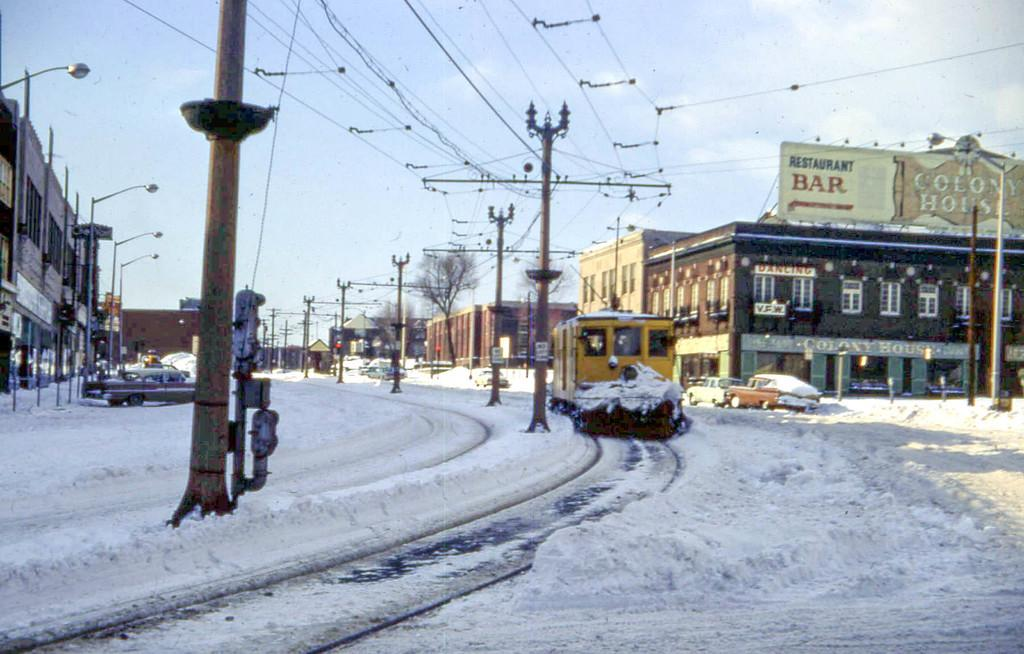<image>
Render a clear and concise summary of the photo. A snowy street with a restaurant named Colony House. 